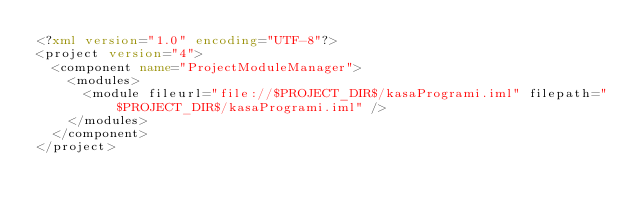<code> <loc_0><loc_0><loc_500><loc_500><_XML_><?xml version="1.0" encoding="UTF-8"?>
<project version="4">
  <component name="ProjectModuleManager">
    <modules>
      <module fileurl="file://$PROJECT_DIR$/kasaProgrami.iml" filepath="$PROJECT_DIR$/kasaProgrami.iml" />
    </modules>
  </component>
</project></code> 